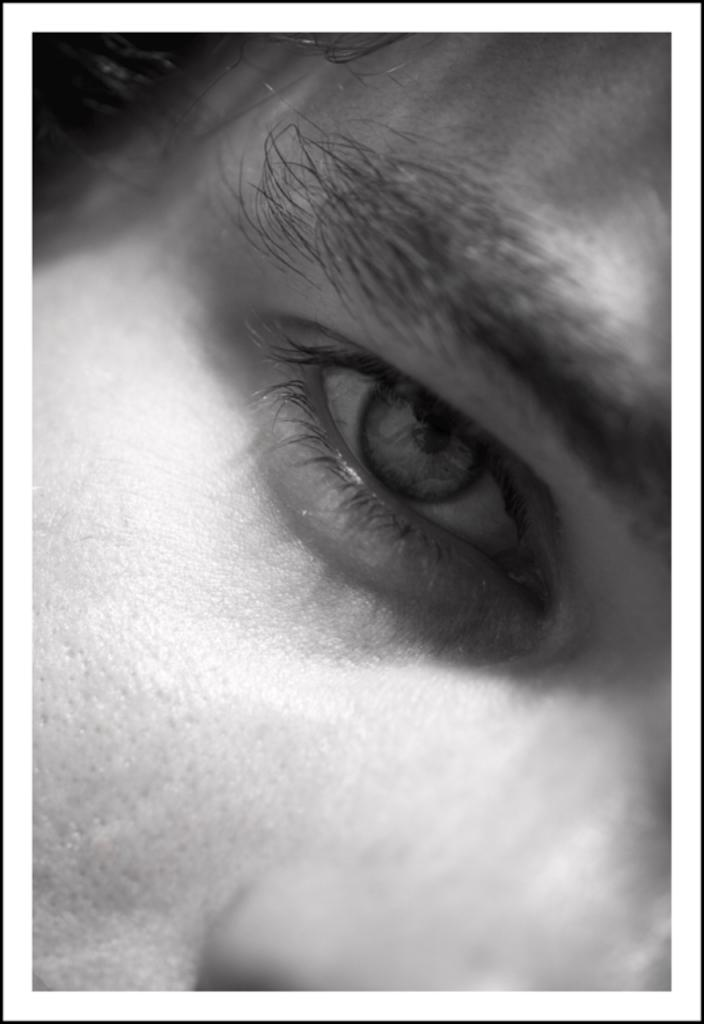What is the color scheme of the image? The image is black and white. What facial feature can be seen in the image? There is only one eye visible in the image. What other facial features can be seen in the image? There is a nose and eyebrows visible in the image. Can you hear the person in the image laughing? There is no sound in the image, so it is not possible to hear the person laughing. 